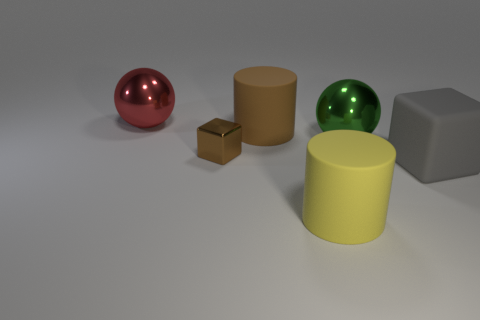How are the objects on the table illuminated? The lighting on the objects suggests a diffuse overhead light source, as indicated by the soft shadows under each object and the gentle reflections on the glossy surfaces.  Do these objects have a particular meaning when placed together like this? This arrangement doesn't seem to convey a specific meaning; it's more likely a setup to demonstrate various materials and shapes, perhaps for a study in light and texture. 